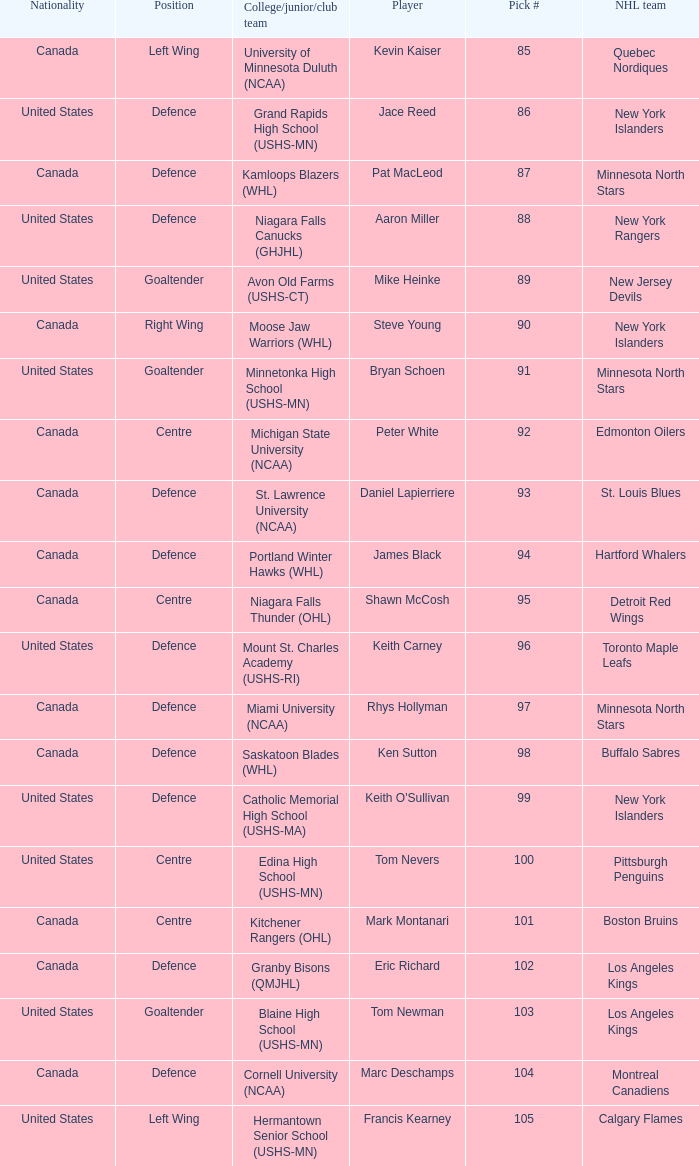What draft position was marc deschamps? 104.0. I'm looking to parse the entire table for insights. Could you assist me with that? {'header': ['Nationality', 'Position', 'College/junior/club team', 'Player', 'Pick #', 'NHL team'], 'rows': [['Canada', 'Left Wing', 'University of Minnesota Duluth (NCAA)', 'Kevin Kaiser', '85', 'Quebec Nordiques'], ['United States', 'Defence', 'Grand Rapids High School (USHS-MN)', 'Jace Reed', '86', 'New York Islanders'], ['Canada', 'Defence', 'Kamloops Blazers (WHL)', 'Pat MacLeod', '87', 'Minnesota North Stars'], ['United States', 'Defence', 'Niagara Falls Canucks (GHJHL)', 'Aaron Miller', '88', 'New York Rangers'], ['United States', 'Goaltender', 'Avon Old Farms (USHS-CT)', 'Mike Heinke', '89', 'New Jersey Devils'], ['Canada', 'Right Wing', 'Moose Jaw Warriors (WHL)', 'Steve Young', '90', 'New York Islanders'], ['United States', 'Goaltender', 'Minnetonka High School (USHS-MN)', 'Bryan Schoen', '91', 'Minnesota North Stars'], ['Canada', 'Centre', 'Michigan State University (NCAA)', 'Peter White', '92', 'Edmonton Oilers'], ['Canada', 'Defence', 'St. Lawrence University (NCAA)', 'Daniel Lapierriere', '93', 'St. Louis Blues'], ['Canada', 'Defence', 'Portland Winter Hawks (WHL)', 'James Black', '94', 'Hartford Whalers'], ['Canada', 'Centre', 'Niagara Falls Thunder (OHL)', 'Shawn McCosh', '95', 'Detroit Red Wings'], ['United States', 'Defence', 'Mount St. Charles Academy (USHS-RI)', 'Keith Carney', '96', 'Toronto Maple Leafs'], ['Canada', 'Defence', 'Miami University (NCAA)', 'Rhys Hollyman', '97', 'Minnesota North Stars'], ['Canada', 'Defence', 'Saskatoon Blades (WHL)', 'Ken Sutton', '98', 'Buffalo Sabres'], ['United States', 'Defence', 'Catholic Memorial High School (USHS-MA)', "Keith O'Sullivan", '99', 'New York Islanders'], ['United States', 'Centre', 'Edina High School (USHS-MN)', 'Tom Nevers', '100', 'Pittsburgh Penguins'], ['Canada', 'Centre', 'Kitchener Rangers (OHL)', 'Mark Montanari', '101', 'Boston Bruins'], ['Canada', 'Defence', 'Granby Bisons (QMJHL)', 'Eric Richard', '102', 'Los Angeles Kings'], ['United States', 'Goaltender', 'Blaine High School (USHS-MN)', 'Tom Newman', '103', 'Los Angeles Kings'], ['Canada', 'Defence', 'Cornell University (NCAA)', 'Marc Deschamps', '104', 'Montreal Canadiens'], ['United States', 'Left Wing', 'Hermantown Senior School (USHS-MN)', 'Francis Kearney', '105', 'Calgary Flames']]} 